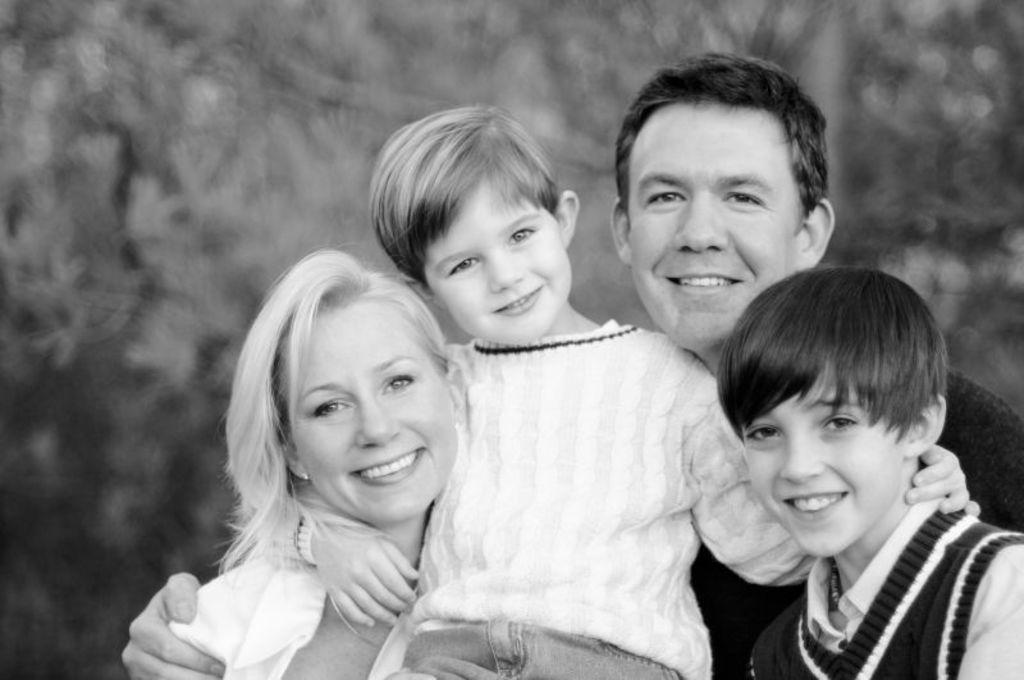Can you describe this image briefly? In this picture there is a woman who is wearing a white dress, besides her there is a man who is wearing a black dress and. He is holding a boy. In the bottom right there is another boy. He is wearing sweater and shirt. Everyone is smiling. In background i can see many trees. 